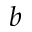Convert formula to latex. <formula><loc_0><loc_0><loc_500><loc_500>b</formula> 